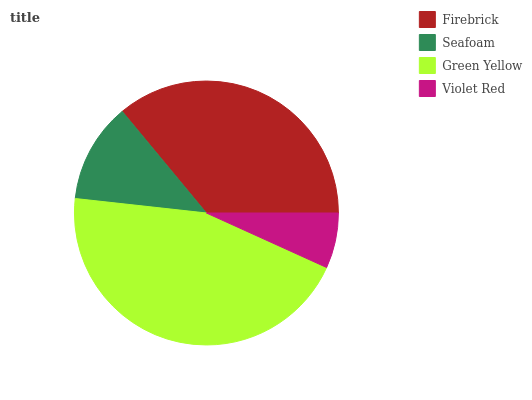Is Violet Red the minimum?
Answer yes or no. Yes. Is Green Yellow the maximum?
Answer yes or no. Yes. Is Seafoam the minimum?
Answer yes or no. No. Is Seafoam the maximum?
Answer yes or no. No. Is Firebrick greater than Seafoam?
Answer yes or no. Yes. Is Seafoam less than Firebrick?
Answer yes or no. Yes. Is Seafoam greater than Firebrick?
Answer yes or no. No. Is Firebrick less than Seafoam?
Answer yes or no. No. Is Firebrick the high median?
Answer yes or no. Yes. Is Seafoam the low median?
Answer yes or no. Yes. Is Green Yellow the high median?
Answer yes or no. No. Is Violet Red the low median?
Answer yes or no. No. 